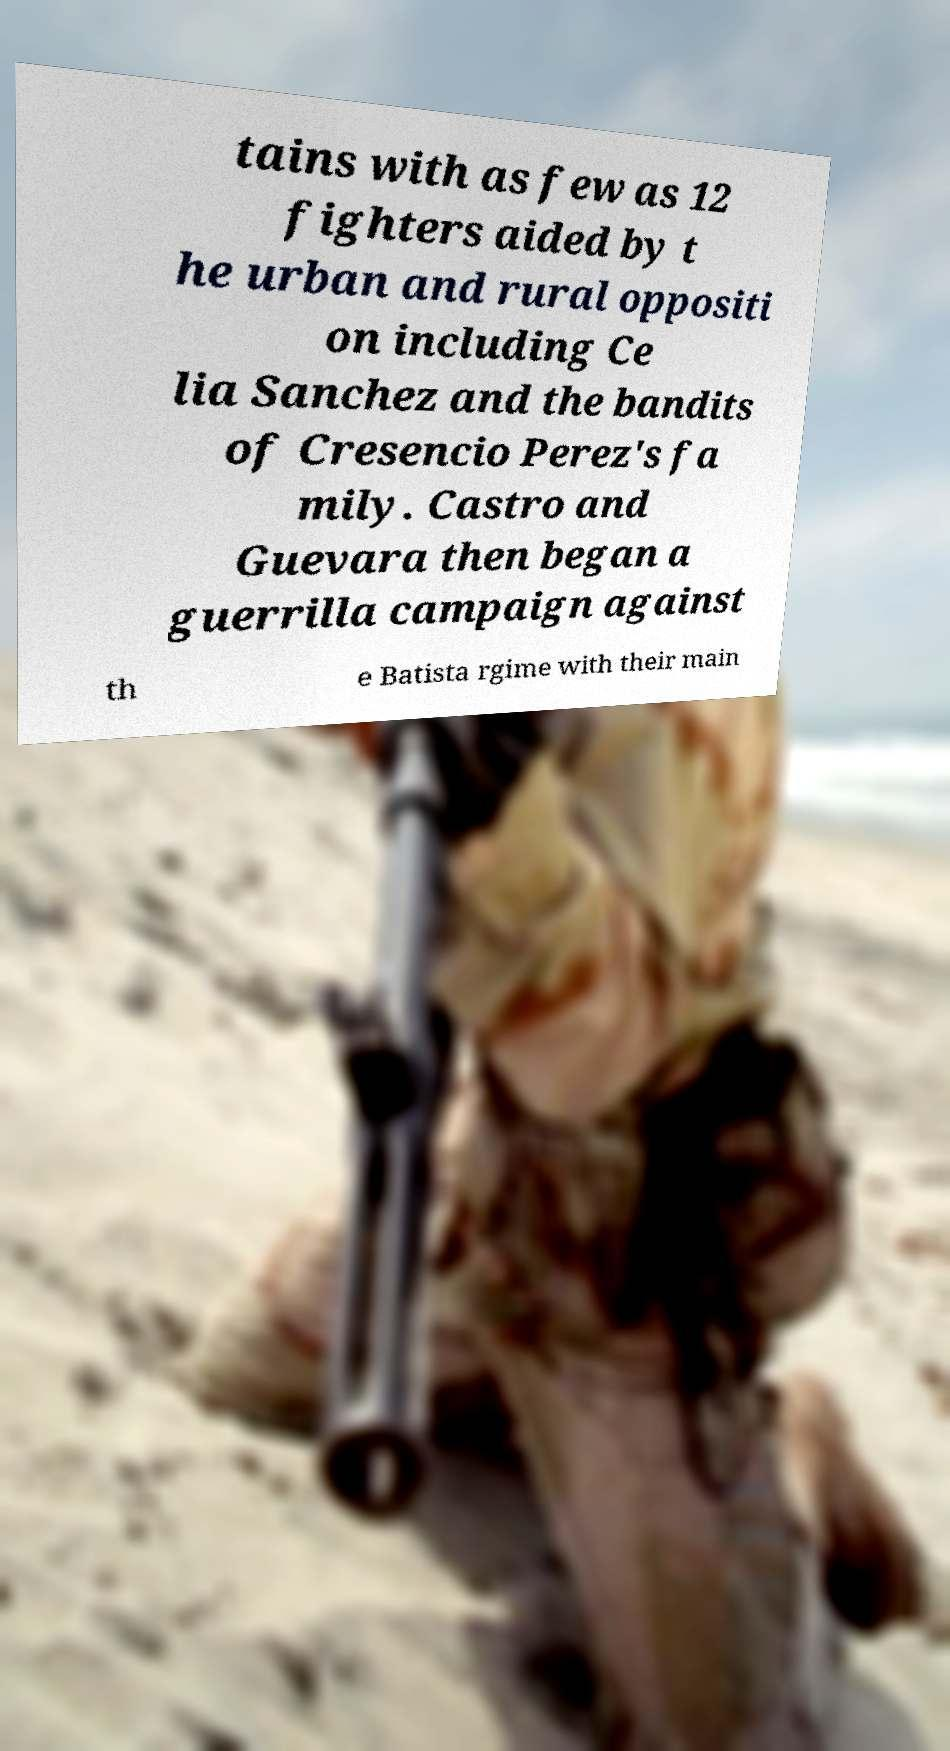Can you read and provide the text displayed in the image?This photo seems to have some interesting text. Can you extract and type it out for me? tains with as few as 12 fighters aided by t he urban and rural oppositi on including Ce lia Sanchez and the bandits of Cresencio Perez's fa mily. Castro and Guevara then began a guerrilla campaign against th e Batista rgime with their main 